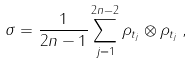<formula> <loc_0><loc_0><loc_500><loc_500>\sigma = \frac { 1 } { 2 n - 1 } \sum _ { j = 1 } ^ { 2 n - 2 } \rho _ { t _ { j } } \otimes \rho _ { t _ { j } } \, ,</formula> 